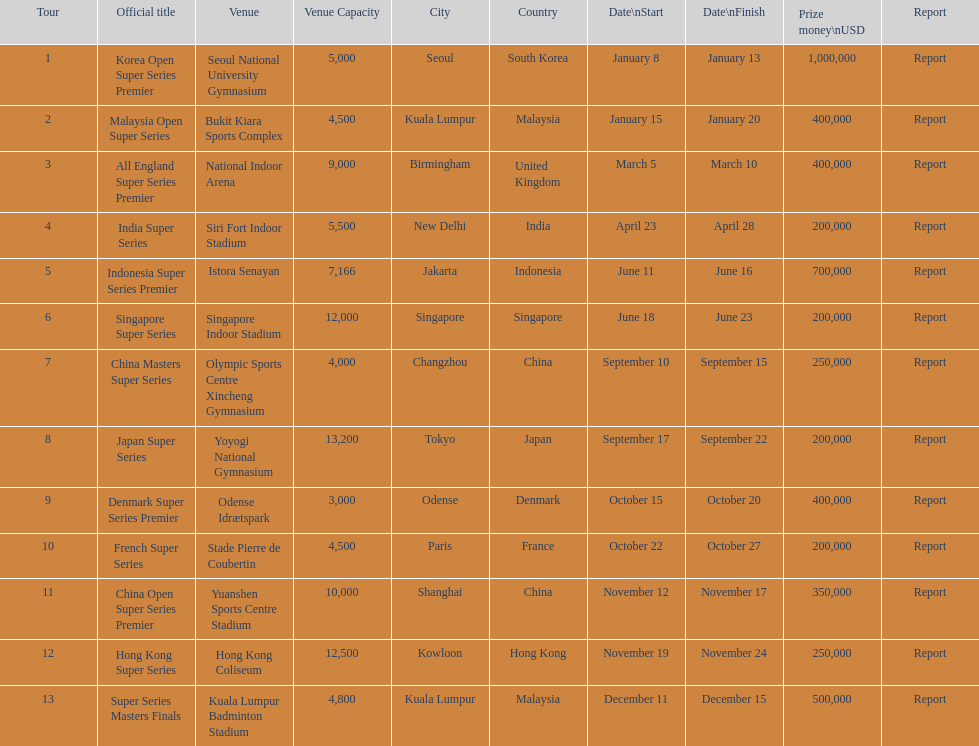Does the malaysia open super series pay more or less than french super series? More. 